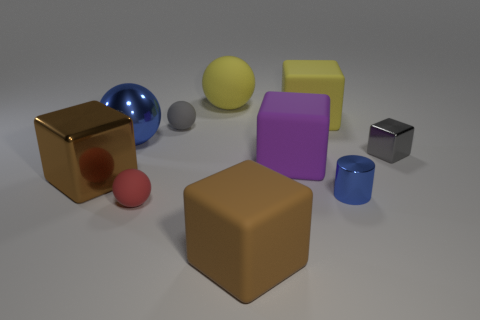Subtract 1 balls. How many balls are left? 3 Subtract all gray blocks. How many blocks are left? 4 Subtract all tiny blocks. How many blocks are left? 4 Subtract all purple spheres. Subtract all green blocks. How many spheres are left? 4 Subtract all cylinders. How many objects are left? 9 Subtract 1 yellow cubes. How many objects are left? 9 Subtract all big cyan rubber cylinders. Subtract all shiny balls. How many objects are left? 9 Add 8 brown metallic cubes. How many brown metallic cubes are left? 9 Add 5 gray shiny objects. How many gray shiny objects exist? 6 